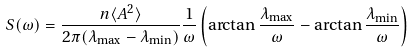Convert formula to latex. <formula><loc_0><loc_0><loc_500><loc_500>S ( \omega ) = \frac { n \langle A ^ { 2 } \rangle } { 2 \pi ( \lambda _ { \max } - \lambda _ { \min } ) } \frac { 1 } { \omega } \left ( \arctan \frac { \lambda _ { \max } } { \omega } - \arctan \frac { \lambda _ { \min } } { \omega } \right )</formula> 